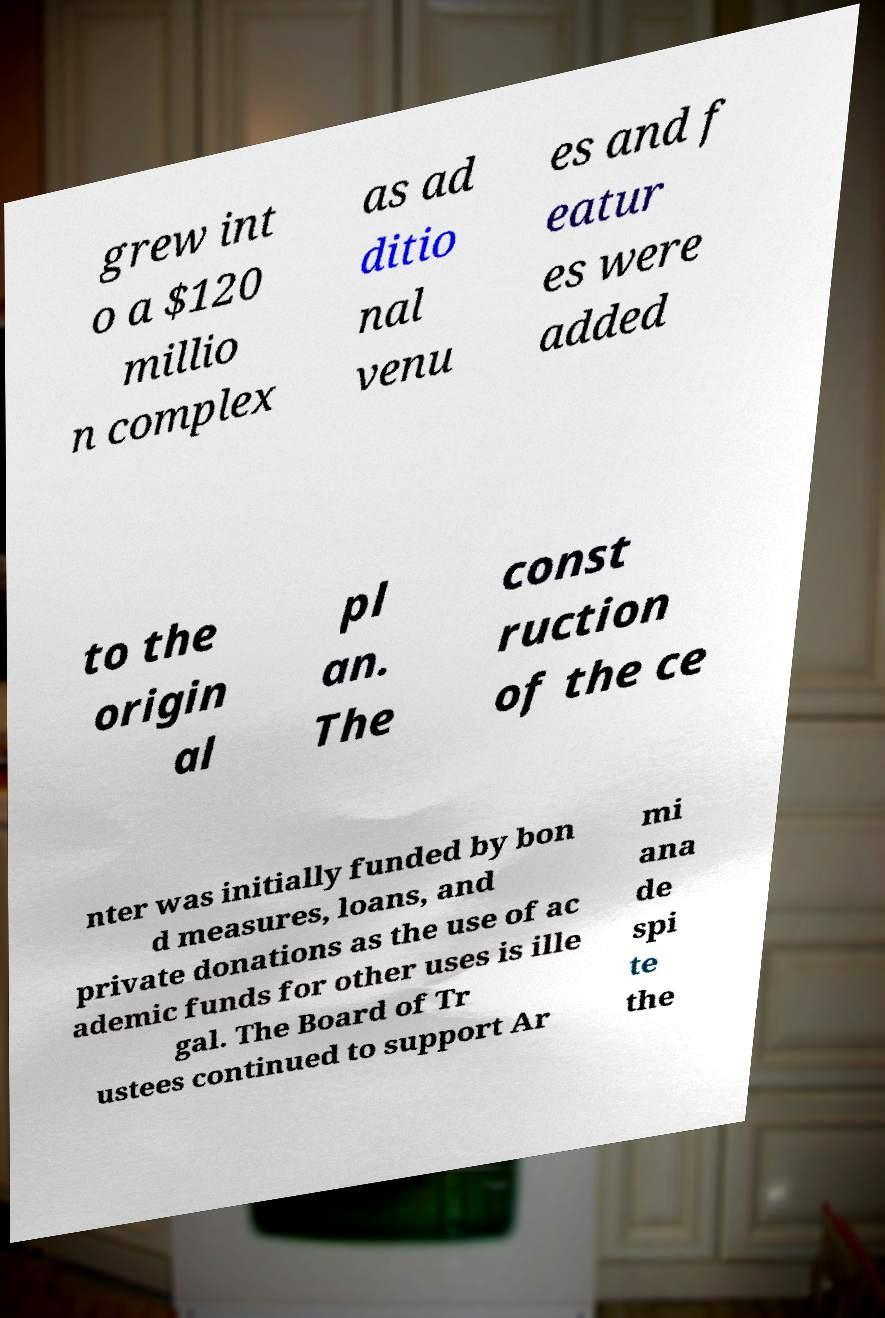What messages or text are displayed in this image? I need them in a readable, typed format. grew int o a $120 millio n complex as ad ditio nal venu es and f eatur es were added to the origin al pl an. The const ruction of the ce nter was initially funded by bon d measures, loans, and private donations as the use of ac ademic funds for other uses is ille gal. The Board of Tr ustees continued to support Ar mi ana de spi te the 